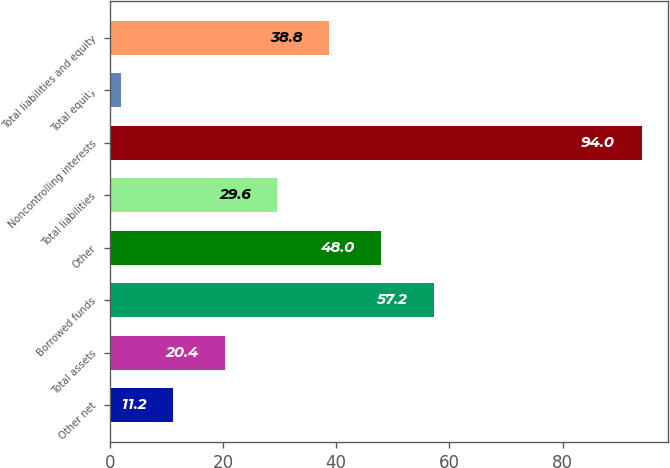<chart> <loc_0><loc_0><loc_500><loc_500><bar_chart><fcel>Other net<fcel>Total assets<fcel>Borrowed funds<fcel>Other<fcel>Total liabilities<fcel>Noncontrolling interests<fcel>Total equity<fcel>Total liabilities and equity<nl><fcel>11.2<fcel>20.4<fcel>57.2<fcel>48<fcel>29.6<fcel>94<fcel>2<fcel>38.8<nl></chart> 